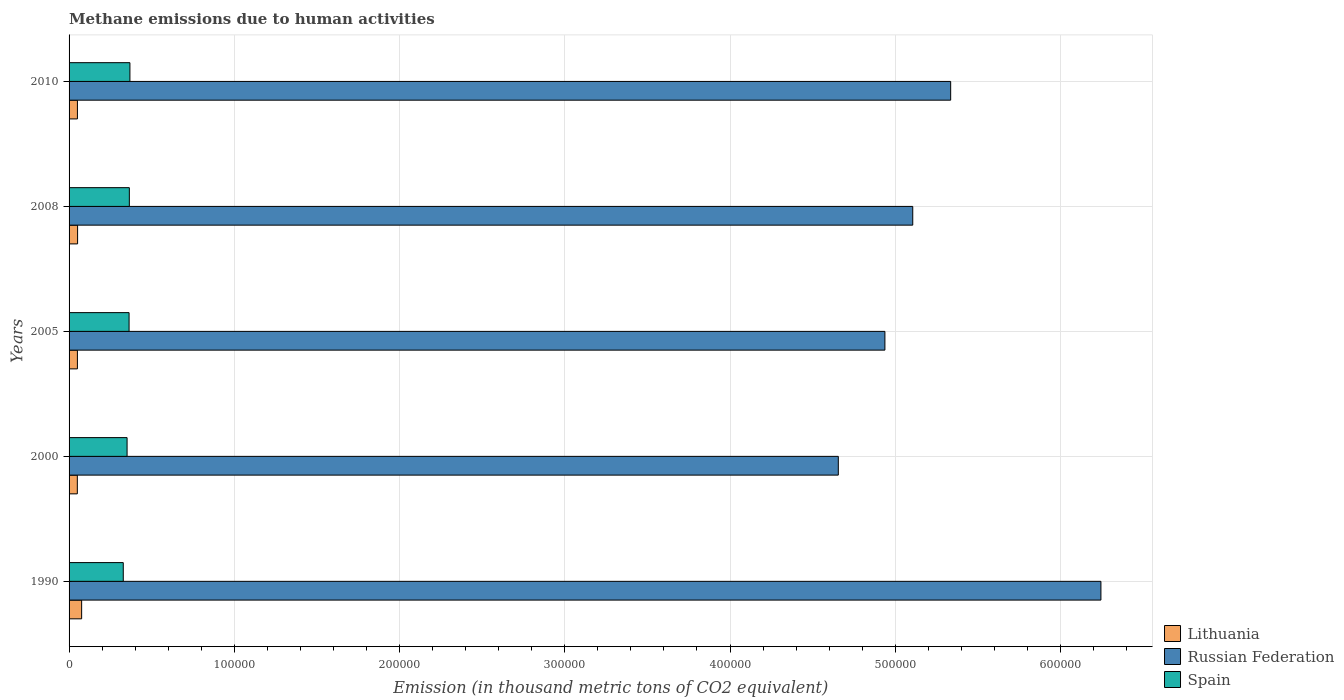How many different coloured bars are there?
Provide a succinct answer. 3. How many groups of bars are there?
Provide a succinct answer. 5. Are the number of bars on each tick of the Y-axis equal?
Offer a terse response. Yes. How many bars are there on the 5th tick from the top?
Your answer should be compact. 3. How many bars are there on the 4th tick from the bottom?
Offer a terse response. 3. What is the label of the 4th group of bars from the top?
Provide a succinct answer. 2000. In how many cases, is the number of bars for a given year not equal to the number of legend labels?
Provide a short and direct response. 0. What is the amount of methane emitted in Spain in 2008?
Your answer should be compact. 3.65e+04. Across all years, what is the maximum amount of methane emitted in Spain?
Offer a very short reply. 3.68e+04. Across all years, what is the minimum amount of methane emitted in Lithuania?
Provide a succinct answer. 5000.2. In which year was the amount of methane emitted in Russian Federation minimum?
Offer a terse response. 2000. What is the total amount of methane emitted in Spain in the graph?
Offer a terse response. 1.78e+05. What is the difference between the amount of methane emitted in Lithuania in 1990 and that in 2010?
Your response must be concise. 2551.4. What is the difference between the amount of methane emitted in Russian Federation in 2010 and the amount of methane emitted in Spain in 2000?
Provide a succinct answer. 4.98e+05. What is the average amount of methane emitted in Lithuania per year?
Your answer should be compact. 5570.8. In the year 2000, what is the difference between the amount of methane emitted in Spain and amount of methane emitted in Russian Federation?
Offer a terse response. -4.30e+05. In how many years, is the amount of methane emitted in Lithuania greater than 60000 thousand metric tons?
Give a very brief answer. 0. What is the ratio of the amount of methane emitted in Spain in 2000 to that in 2008?
Provide a succinct answer. 0.96. Is the amount of methane emitted in Lithuania in 2000 less than that in 2005?
Make the answer very short. Yes. What is the difference between the highest and the second highest amount of methane emitted in Spain?
Offer a terse response. 347.7. What is the difference between the highest and the lowest amount of methane emitted in Russian Federation?
Keep it short and to the point. 1.59e+05. In how many years, is the amount of methane emitted in Spain greater than the average amount of methane emitted in Spain taken over all years?
Provide a short and direct response. 3. Is the sum of the amount of methane emitted in Russian Federation in 1990 and 2005 greater than the maximum amount of methane emitted in Spain across all years?
Keep it short and to the point. Yes. What does the 2nd bar from the top in 2010 represents?
Keep it short and to the point. Russian Federation. Is it the case that in every year, the sum of the amount of methane emitted in Russian Federation and amount of methane emitted in Lithuania is greater than the amount of methane emitted in Spain?
Offer a terse response. Yes. How many bars are there?
Give a very brief answer. 15. Are all the bars in the graph horizontal?
Ensure brevity in your answer.  Yes. Does the graph contain any zero values?
Offer a very short reply. No. Does the graph contain grids?
Provide a succinct answer. Yes. What is the title of the graph?
Offer a terse response. Methane emissions due to human activities. What is the label or title of the X-axis?
Offer a terse response. Emission (in thousand metric tons of CO2 equivalent). What is the Emission (in thousand metric tons of CO2 equivalent) of Lithuania in 1990?
Give a very brief answer. 7603.6. What is the Emission (in thousand metric tons of CO2 equivalent) in Russian Federation in 1990?
Your answer should be very brief. 6.24e+05. What is the Emission (in thousand metric tons of CO2 equivalent) of Spain in 1990?
Ensure brevity in your answer.  3.28e+04. What is the Emission (in thousand metric tons of CO2 equivalent) in Lithuania in 2000?
Provide a succinct answer. 5000.2. What is the Emission (in thousand metric tons of CO2 equivalent) of Russian Federation in 2000?
Offer a very short reply. 4.66e+05. What is the Emission (in thousand metric tons of CO2 equivalent) of Spain in 2000?
Provide a succinct answer. 3.51e+04. What is the Emission (in thousand metric tons of CO2 equivalent) of Lithuania in 2005?
Provide a short and direct response. 5042.2. What is the Emission (in thousand metric tons of CO2 equivalent) in Russian Federation in 2005?
Give a very brief answer. 4.94e+05. What is the Emission (in thousand metric tons of CO2 equivalent) of Spain in 2005?
Make the answer very short. 3.63e+04. What is the Emission (in thousand metric tons of CO2 equivalent) in Lithuania in 2008?
Offer a terse response. 5155.8. What is the Emission (in thousand metric tons of CO2 equivalent) in Russian Federation in 2008?
Your answer should be very brief. 5.11e+05. What is the Emission (in thousand metric tons of CO2 equivalent) in Spain in 2008?
Provide a succinct answer. 3.65e+04. What is the Emission (in thousand metric tons of CO2 equivalent) in Lithuania in 2010?
Offer a very short reply. 5052.2. What is the Emission (in thousand metric tons of CO2 equivalent) in Russian Federation in 2010?
Your answer should be very brief. 5.34e+05. What is the Emission (in thousand metric tons of CO2 equivalent) of Spain in 2010?
Provide a succinct answer. 3.68e+04. Across all years, what is the maximum Emission (in thousand metric tons of CO2 equivalent) in Lithuania?
Your answer should be compact. 7603.6. Across all years, what is the maximum Emission (in thousand metric tons of CO2 equivalent) of Russian Federation?
Provide a short and direct response. 6.24e+05. Across all years, what is the maximum Emission (in thousand metric tons of CO2 equivalent) in Spain?
Your response must be concise. 3.68e+04. Across all years, what is the minimum Emission (in thousand metric tons of CO2 equivalent) in Lithuania?
Make the answer very short. 5000.2. Across all years, what is the minimum Emission (in thousand metric tons of CO2 equivalent) in Russian Federation?
Offer a very short reply. 4.66e+05. Across all years, what is the minimum Emission (in thousand metric tons of CO2 equivalent) of Spain?
Ensure brevity in your answer.  3.28e+04. What is the total Emission (in thousand metric tons of CO2 equivalent) in Lithuania in the graph?
Offer a very short reply. 2.79e+04. What is the total Emission (in thousand metric tons of CO2 equivalent) of Russian Federation in the graph?
Ensure brevity in your answer.  2.63e+06. What is the total Emission (in thousand metric tons of CO2 equivalent) of Spain in the graph?
Make the answer very short. 1.78e+05. What is the difference between the Emission (in thousand metric tons of CO2 equivalent) of Lithuania in 1990 and that in 2000?
Your answer should be compact. 2603.4. What is the difference between the Emission (in thousand metric tons of CO2 equivalent) in Russian Federation in 1990 and that in 2000?
Keep it short and to the point. 1.59e+05. What is the difference between the Emission (in thousand metric tons of CO2 equivalent) of Spain in 1990 and that in 2000?
Your response must be concise. -2310.4. What is the difference between the Emission (in thousand metric tons of CO2 equivalent) in Lithuania in 1990 and that in 2005?
Your response must be concise. 2561.4. What is the difference between the Emission (in thousand metric tons of CO2 equivalent) in Russian Federation in 1990 and that in 2005?
Your response must be concise. 1.31e+05. What is the difference between the Emission (in thousand metric tons of CO2 equivalent) in Spain in 1990 and that in 2005?
Your response must be concise. -3519.1. What is the difference between the Emission (in thousand metric tons of CO2 equivalent) in Lithuania in 1990 and that in 2008?
Your response must be concise. 2447.8. What is the difference between the Emission (in thousand metric tons of CO2 equivalent) in Russian Federation in 1990 and that in 2008?
Provide a succinct answer. 1.14e+05. What is the difference between the Emission (in thousand metric tons of CO2 equivalent) in Spain in 1990 and that in 2008?
Provide a succinct answer. -3681.4. What is the difference between the Emission (in thousand metric tons of CO2 equivalent) in Lithuania in 1990 and that in 2010?
Provide a short and direct response. 2551.4. What is the difference between the Emission (in thousand metric tons of CO2 equivalent) of Russian Federation in 1990 and that in 2010?
Your answer should be compact. 9.09e+04. What is the difference between the Emission (in thousand metric tons of CO2 equivalent) in Spain in 1990 and that in 2010?
Your answer should be compact. -4029.1. What is the difference between the Emission (in thousand metric tons of CO2 equivalent) of Lithuania in 2000 and that in 2005?
Give a very brief answer. -42. What is the difference between the Emission (in thousand metric tons of CO2 equivalent) of Russian Federation in 2000 and that in 2005?
Your answer should be very brief. -2.82e+04. What is the difference between the Emission (in thousand metric tons of CO2 equivalent) in Spain in 2000 and that in 2005?
Provide a succinct answer. -1208.7. What is the difference between the Emission (in thousand metric tons of CO2 equivalent) of Lithuania in 2000 and that in 2008?
Keep it short and to the point. -155.6. What is the difference between the Emission (in thousand metric tons of CO2 equivalent) of Russian Federation in 2000 and that in 2008?
Your answer should be very brief. -4.51e+04. What is the difference between the Emission (in thousand metric tons of CO2 equivalent) of Spain in 2000 and that in 2008?
Make the answer very short. -1371. What is the difference between the Emission (in thousand metric tons of CO2 equivalent) in Lithuania in 2000 and that in 2010?
Keep it short and to the point. -52. What is the difference between the Emission (in thousand metric tons of CO2 equivalent) in Russian Federation in 2000 and that in 2010?
Provide a short and direct response. -6.80e+04. What is the difference between the Emission (in thousand metric tons of CO2 equivalent) of Spain in 2000 and that in 2010?
Your answer should be very brief. -1718.7. What is the difference between the Emission (in thousand metric tons of CO2 equivalent) of Lithuania in 2005 and that in 2008?
Give a very brief answer. -113.6. What is the difference between the Emission (in thousand metric tons of CO2 equivalent) in Russian Federation in 2005 and that in 2008?
Offer a very short reply. -1.69e+04. What is the difference between the Emission (in thousand metric tons of CO2 equivalent) of Spain in 2005 and that in 2008?
Your answer should be very brief. -162.3. What is the difference between the Emission (in thousand metric tons of CO2 equivalent) in Russian Federation in 2005 and that in 2010?
Your answer should be very brief. -3.98e+04. What is the difference between the Emission (in thousand metric tons of CO2 equivalent) of Spain in 2005 and that in 2010?
Ensure brevity in your answer.  -510. What is the difference between the Emission (in thousand metric tons of CO2 equivalent) of Lithuania in 2008 and that in 2010?
Keep it short and to the point. 103.6. What is the difference between the Emission (in thousand metric tons of CO2 equivalent) of Russian Federation in 2008 and that in 2010?
Ensure brevity in your answer.  -2.29e+04. What is the difference between the Emission (in thousand metric tons of CO2 equivalent) in Spain in 2008 and that in 2010?
Offer a terse response. -347.7. What is the difference between the Emission (in thousand metric tons of CO2 equivalent) in Lithuania in 1990 and the Emission (in thousand metric tons of CO2 equivalent) in Russian Federation in 2000?
Offer a very short reply. -4.58e+05. What is the difference between the Emission (in thousand metric tons of CO2 equivalent) of Lithuania in 1990 and the Emission (in thousand metric tons of CO2 equivalent) of Spain in 2000?
Offer a terse response. -2.75e+04. What is the difference between the Emission (in thousand metric tons of CO2 equivalent) in Russian Federation in 1990 and the Emission (in thousand metric tons of CO2 equivalent) in Spain in 2000?
Your answer should be very brief. 5.89e+05. What is the difference between the Emission (in thousand metric tons of CO2 equivalent) of Lithuania in 1990 and the Emission (in thousand metric tons of CO2 equivalent) of Russian Federation in 2005?
Provide a short and direct response. -4.86e+05. What is the difference between the Emission (in thousand metric tons of CO2 equivalent) in Lithuania in 1990 and the Emission (in thousand metric tons of CO2 equivalent) in Spain in 2005?
Make the answer very short. -2.87e+04. What is the difference between the Emission (in thousand metric tons of CO2 equivalent) in Russian Federation in 1990 and the Emission (in thousand metric tons of CO2 equivalent) in Spain in 2005?
Provide a succinct answer. 5.88e+05. What is the difference between the Emission (in thousand metric tons of CO2 equivalent) in Lithuania in 1990 and the Emission (in thousand metric tons of CO2 equivalent) in Russian Federation in 2008?
Make the answer very short. -5.03e+05. What is the difference between the Emission (in thousand metric tons of CO2 equivalent) of Lithuania in 1990 and the Emission (in thousand metric tons of CO2 equivalent) of Spain in 2008?
Provide a short and direct response. -2.89e+04. What is the difference between the Emission (in thousand metric tons of CO2 equivalent) of Russian Federation in 1990 and the Emission (in thousand metric tons of CO2 equivalent) of Spain in 2008?
Offer a terse response. 5.88e+05. What is the difference between the Emission (in thousand metric tons of CO2 equivalent) of Lithuania in 1990 and the Emission (in thousand metric tons of CO2 equivalent) of Russian Federation in 2010?
Ensure brevity in your answer.  -5.26e+05. What is the difference between the Emission (in thousand metric tons of CO2 equivalent) in Lithuania in 1990 and the Emission (in thousand metric tons of CO2 equivalent) in Spain in 2010?
Give a very brief answer. -2.92e+04. What is the difference between the Emission (in thousand metric tons of CO2 equivalent) of Russian Federation in 1990 and the Emission (in thousand metric tons of CO2 equivalent) of Spain in 2010?
Offer a terse response. 5.88e+05. What is the difference between the Emission (in thousand metric tons of CO2 equivalent) of Lithuania in 2000 and the Emission (in thousand metric tons of CO2 equivalent) of Russian Federation in 2005?
Give a very brief answer. -4.89e+05. What is the difference between the Emission (in thousand metric tons of CO2 equivalent) of Lithuania in 2000 and the Emission (in thousand metric tons of CO2 equivalent) of Spain in 2005?
Your answer should be compact. -3.13e+04. What is the difference between the Emission (in thousand metric tons of CO2 equivalent) in Russian Federation in 2000 and the Emission (in thousand metric tons of CO2 equivalent) in Spain in 2005?
Give a very brief answer. 4.29e+05. What is the difference between the Emission (in thousand metric tons of CO2 equivalent) of Lithuania in 2000 and the Emission (in thousand metric tons of CO2 equivalent) of Russian Federation in 2008?
Make the answer very short. -5.06e+05. What is the difference between the Emission (in thousand metric tons of CO2 equivalent) in Lithuania in 2000 and the Emission (in thousand metric tons of CO2 equivalent) in Spain in 2008?
Offer a very short reply. -3.15e+04. What is the difference between the Emission (in thousand metric tons of CO2 equivalent) in Russian Federation in 2000 and the Emission (in thousand metric tons of CO2 equivalent) in Spain in 2008?
Offer a terse response. 4.29e+05. What is the difference between the Emission (in thousand metric tons of CO2 equivalent) of Lithuania in 2000 and the Emission (in thousand metric tons of CO2 equivalent) of Russian Federation in 2010?
Give a very brief answer. -5.29e+05. What is the difference between the Emission (in thousand metric tons of CO2 equivalent) of Lithuania in 2000 and the Emission (in thousand metric tons of CO2 equivalent) of Spain in 2010?
Keep it short and to the point. -3.18e+04. What is the difference between the Emission (in thousand metric tons of CO2 equivalent) in Russian Federation in 2000 and the Emission (in thousand metric tons of CO2 equivalent) in Spain in 2010?
Your answer should be compact. 4.29e+05. What is the difference between the Emission (in thousand metric tons of CO2 equivalent) in Lithuania in 2005 and the Emission (in thousand metric tons of CO2 equivalent) in Russian Federation in 2008?
Give a very brief answer. -5.06e+05. What is the difference between the Emission (in thousand metric tons of CO2 equivalent) of Lithuania in 2005 and the Emission (in thousand metric tons of CO2 equivalent) of Spain in 2008?
Your response must be concise. -3.14e+04. What is the difference between the Emission (in thousand metric tons of CO2 equivalent) in Russian Federation in 2005 and the Emission (in thousand metric tons of CO2 equivalent) in Spain in 2008?
Make the answer very short. 4.57e+05. What is the difference between the Emission (in thousand metric tons of CO2 equivalent) in Lithuania in 2005 and the Emission (in thousand metric tons of CO2 equivalent) in Russian Federation in 2010?
Provide a succinct answer. -5.29e+05. What is the difference between the Emission (in thousand metric tons of CO2 equivalent) of Lithuania in 2005 and the Emission (in thousand metric tons of CO2 equivalent) of Spain in 2010?
Provide a succinct answer. -3.18e+04. What is the difference between the Emission (in thousand metric tons of CO2 equivalent) in Russian Federation in 2005 and the Emission (in thousand metric tons of CO2 equivalent) in Spain in 2010?
Offer a terse response. 4.57e+05. What is the difference between the Emission (in thousand metric tons of CO2 equivalent) in Lithuania in 2008 and the Emission (in thousand metric tons of CO2 equivalent) in Russian Federation in 2010?
Your answer should be very brief. -5.28e+05. What is the difference between the Emission (in thousand metric tons of CO2 equivalent) of Lithuania in 2008 and the Emission (in thousand metric tons of CO2 equivalent) of Spain in 2010?
Make the answer very short. -3.17e+04. What is the difference between the Emission (in thousand metric tons of CO2 equivalent) of Russian Federation in 2008 and the Emission (in thousand metric tons of CO2 equivalent) of Spain in 2010?
Provide a succinct answer. 4.74e+05. What is the average Emission (in thousand metric tons of CO2 equivalent) of Lithuania per year?
Provide a succinct answer. 5570.8. What is the average Emission (in thousand metric tons of CO2 equivalent) in Russian Federation per year?
Give a very brief answer. 5.26e+05. What is the average Emission (in thousand metric tons of CO2 equivalent) of Spain per year?
Provide a succinct answer. 3.55e+04. In the year 1990, what is the difference between the Emission (in thousand metric tons of CO2 equivalent) of Lithuania and Emission (in thousand metric tons of CO2 equivalent) of Russian Federation?
Give a very brief answer. -6.17e+05. In the year 1990, what is the difference between the Emission (in thousand metric tons of CO2 equivalent) in Lithuania and Emission (in thousand metric tons of CO2 equivalent) in Spain?
Your response must be concise. -2.52e+04. In the year 1990, what is the difference between the Emission (in thousand metric tons of CO2 equivalent) of Russian Federation and Emission (in thousand metric tons of CO2 equivalent) of Spain?
Your answer should be compact. 5.92e+05. In the year 2000, what is the difference between the Emission (in thousand metric tons of CO2 equivalent) of Lithuania and Emission (in thousand metric tons of CO2 equivalent) of Russian Federation?
Your answer should be compact. -4.61e+05. In the year 2000, what is the difference between the Emission (in thousand metric tons of CO2 equivalent) in Lithuania and Emission (in thousand metric tons of CO2 equivalent) in Spain?
Provide a short and direct response. -3.01e+04. In the year 2000, what is the difference between the Emission (in thousand metric tons of CO2 equivalent) of Russian Federation and Emission (in thousand metric tons of CO2 equivalent) of Spain?
Your response must be concise. 4.30e+05. In the year 2005, what is the difference between the Emission (in thousand metric tons of CO2 equivalent) in Lithuania and Emission (in thousand metric tons of CO2 equivalent) in Russian Federation?
Keep it short and to the point. -4.89e+05. In the year 2005, what is the difference between the Emission (in thousand metric tons of CO2 equivalent) in Lithuania and Emission (in thousand metric tons of CO2 equivalent) in Spain?
Your response must be concise. -3.13e+04. In the year 2005, what is the difference between the Emission (in thousand metric tons of CO2 equivalent) in Russian Federation and Emission (in thousand metric tons of CO2 equivalent) in Spain?
Provide a succinct answer. 4.57e+05. In the year 2008, what is the difference between the Emission (in thousand metric tons of CO2 equivalent) of Lithuania and Emission (in thousand metric tons of CO2 equivalent) of Russian Federation?
Offer a very short reply. -5.05e+05. In the year 2008, what is the difference between the Emission (in thousand metric tons of CO2 equivalent) of Lithuania and Emission (in thousand metric tons of CO2 equivalent) of Spain?
Offer a very short reply. -3.13e+04. In the year 2008, what is the difference between the Emission (in thousand metric tons of CO2 equivalent) in Russian Federation and Emission (in thousand metric tons of CO2 equivalent) in Spain?
Ensure brevity in your answer.  4.74e+05. In the year 2010, what is the difference between the Emission (in thousand metric tons of CO2 equivalent) of Lithuania and Emission (in thousand metric tons of CO2 equivalent) of Russian Federation?
Your response must be concise. -5.28e+05. In the year 2010, what is the difference between the Emission (in thousand metric tons of CO2 equivalent) in Lithuania and Emission (in thousand metric tons of CO2 equivalent) in Spain?
Offer a very short reply. -3.18e+04. In the year 2010, what is the difference between the Emission (in thousand metric tons of CO2 equivalent) in Russian Federation and Emission (in thousand metric tons of CO2 equivalent) in Spain?
Give a very brief answer. 4.97e+05. What is the ratio of the Emission (in thousand metric tons of CO2 equivalent) of Lithuania in 1990 to that in 2000?
Your response must be concise. 1.52. What is the ratio of the Emission (in thousand metric tons of CO2 equivalent) in Russian Federation in 1990 to that in 2000?
Provide a succinct answer. 1.34. What is the ratio of the Emission (in thousand metric tons of CO2 equivalent) of Spain in 1990 to that in 2000?
Ensure brevity in your answer.  0.93. What is the ratio of the Emission (in thousand metric tons of CO2 equivalent) of Lithuania in 1990 to that in 2005?
Your answer should be compact. 1.51. What is the ratio of the Emission (in thousand metric tons of CO2 equivalent) of Russian Federation in 1990 to that in 2005?
Give a very brief answer. 1.26. What is the ratio of the Emission (in thousand metric tons of CO2 equivalent) in Spain in 1990 to that in 2005?
Your answer should be compact. 0.9. What is the ratio of the Emission (in thousand metric tons of CO2 equivalent) of Lithuania in 1990 to that in 2008?
Provide a short and direct response. 1.47. What is the ratio of the Emission (in thousand metric tons of CO2 equivalent) in Russian Federation in 1990 to that in 2008?
Your response must be concise. 1.22. What is the ratio of the Emission (in thousand metric tons of CO2 equivalent) in Spain in 1990 to that in 2008?
Give a very brief answer. 0.9. What is the ratio of the Emission (in thousand metric tons of CO2 equivalent) of Lithuania in 1990 to that in 2010?
Offer a terse response. 1.5. What is the ratio of the Emission (in thousand metric tons of CO2 equivalent) of Russian Federation in 1990 to that in 2010?
Your answer should be very brief. 1.17. What is the ratio of the Emission (in thousand metric tons of CO2 equivalent) of Spain in 1990 to that in 2010?
Give a very brief answer. 0.89. What is the ratio of the Emission (in thousand metric tons of CO2 equivalent) in Lithuania in 2000 to that in 2005?
Keep it short and to the point. 0.99. What is the ratio of the Emission (in thousand metric tons of CO2 equivalent) of Russian Federation in 2000 to that in 2005?
Make the answer very short. 0.94. What is the ratio of the Emission (in thousand metric tons of CO2 equivalent) in Spain in 2000 to that in 2005?
Offer a terse response. 0.97. What is the ratio of the Emission (in thousand metric tons of CO2 equivalent) of Lithuania in 2000 to that in 2008?
Give a very brief answer. 0.97. What is the ratio of the Emission (in thousand metric tons of CO2 equivalent) of Russian Federation in 2000 to that in 2008?
Keep it short and to the point. 0.91. What is the ratio of the Emission (in thousand metric tons of CO2 equivalent) of Spain in 2000 to that in 2008?
Offer a very short reply. 0.96. What is the ratio of the Emission (in thousand metric tons of CO2 equivalent) in Russian Federation in 2000 to that in 2010?
Offer a very short reply. 0.87. What is the ratio of the Emission (in thousand metric tons of CO2 equivalent) of Spain in 2000 to that in 2010?
Your answer should be very brief. 0.95. What is the ratio of the Emission (in thousand metric tons of CO2 equivalent) of Lithuania in 2005 to that in 2008?
Provide a succinct answer. 0.98. What is the ratio of the Emission (in thousand metric tons of CO2 equivalent) of Russian Federation in 2005 to that in 2010?
Ensure brevity in your answer.  0.93. What is the ratio of the Emission (in thousand metric tons of CO2 equivalent) in Spain in 2005 to that in 2010?
Keep it short and to the point. 0.99. What is the ratio of the Emission (in thousand metric tons of CO2 equivalent) of Lithuania in 2008 to that in 2010?
Provide a short and direct response. 1.02. What is the ratio of the Emission (in thousand metric tons of CO2 equivalent) of Spain in 2008 to that in 2010?
Ensure brevity in your answer.  0.99. What is the difference between the highest and the second highest Emission (in thousand metric tons of CO2 equivalent) in Lithuania?
Keep it short and to the point. 2447.8. What is the difference between the highest and the second highest Emission (in thousand metric tons of CO2 equivalent) in Russian Federation?
Offer a very short reply. 9.09e+04. What is the difference between the highest and the second highest Emission (in thousand metric tons of CO2 equivalent) in Spain?
Provide a succinct answer. 347.7. What is the difference between the highest and the lowest Emission (in thousand metric tons of CO2 equivalent) of Lithuania?
Your response must be concise. 2603.4. What is the difference between the highest and the lowest Emission (in thousand metric tons of CO2 equivalent) in Russian Federation?
Provide a succinct answer. 1.59e+05. What is the difference between the highest and the lowest Emission (in thousand metric tons of CO2 equivalent) in Spain?
Keep it short and to the point. 4029.1. 